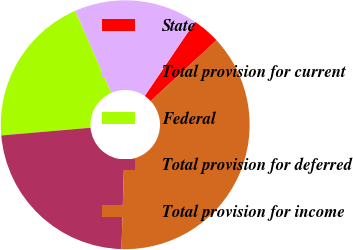Convert chart to OTSL. <chart><loc_0><loc_0><loc_500><loc_500><pie_chart><fcel>State<fcel>Total provision for current<fcel>Federal<fcel>Total provision for deferred<fcel>Total provision for income<nl><fcel>3.63%<fcel>16.07%<fcel>19.78%<fcel>23.15%<fcel>37.36%<nl></chart> 